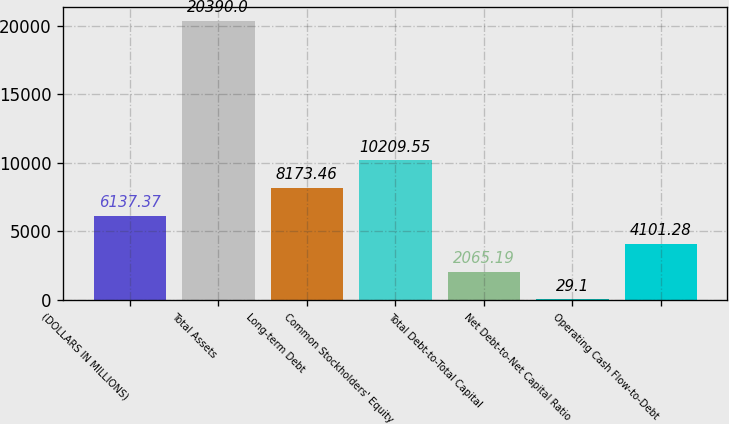Convert chart. <chart><loc_0><loc_0><loc_500><loc_500><bar_chart><fcel>(DOLLARS IN MILLIONS)<fcel>Total Assets<fcel>Long-term Debt<fcel>Common Stockholders' Equity<fcel>Total Debt-to-Total Capital<fcel>Net Debt-to-Net Capital Ratio<fcel>Operating Cash Flow-to-Debt<nl><fcel>6137.37<fcel>20390<fcel>8173.46<fcel>10209.5<fcel>2065.19<fcel>29.1<fcel>4101.28<nl></chart> 